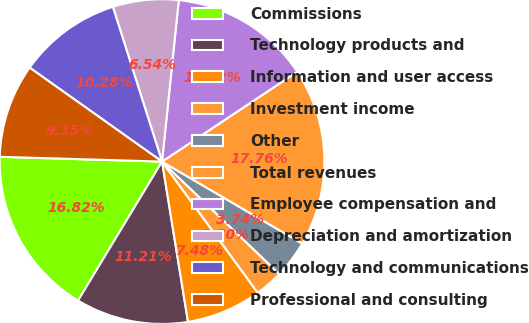<chart> <loc_0><loc_0><loc_500><loc_500><pie_chart><fcel>Commissions<fcel>Technology products and<fcel>Information and user access<fcel>Investment income<fcel>Other<fcel>Total revenues<fcel>Employee compensation and<fcel>Depreciation and amortization<fcel>Technology and communications<fcel>Professional and consulting<nl><fcel>16.82%<fcel>11.21%<fcel>7.48%<fcel>2.8%<fcel>3.74%<fcel>17.76%<fcel>14.02%<fcel>6.54%<fcel>10.28%<fcel>9.35%<nl></chart> 